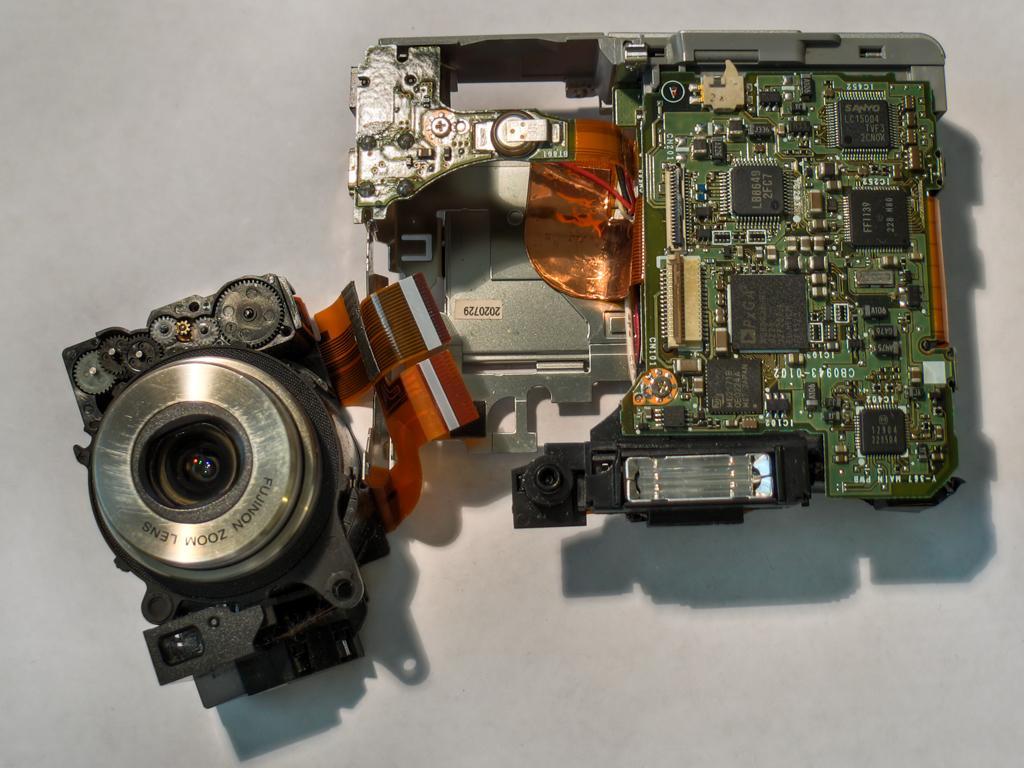Can you describe this image briefly? In the center of the image there is a object on the surface. 